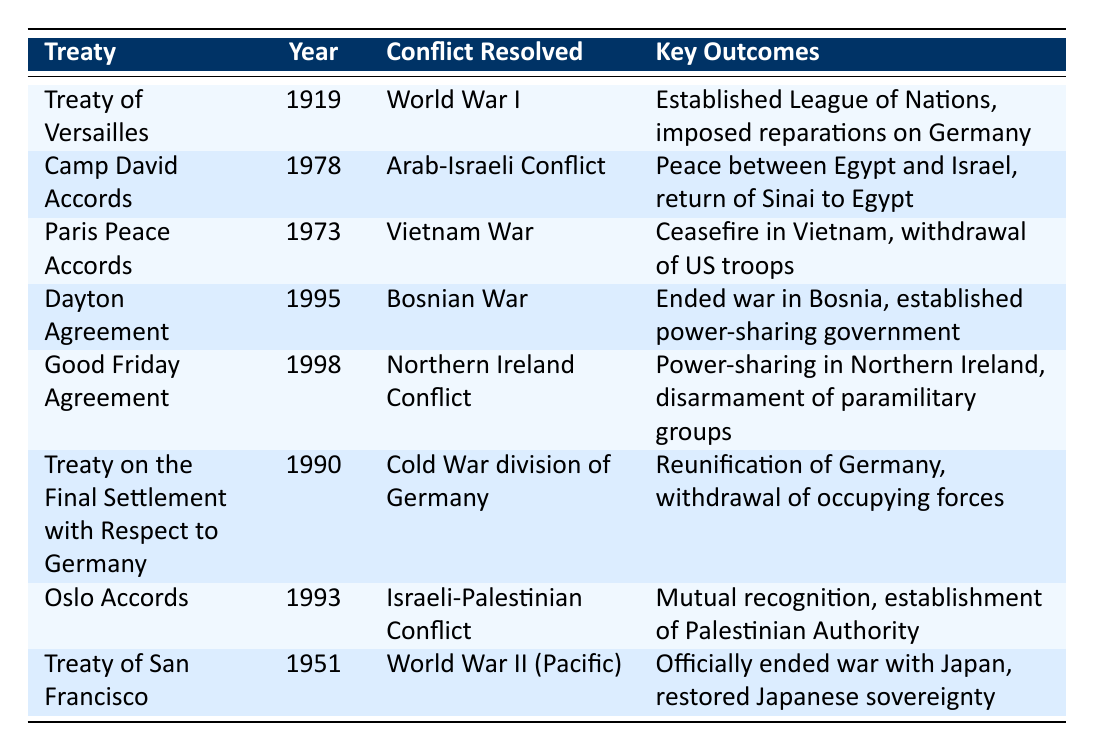What year was the Treaty of Versailles signed? The table lists the year for the Treaty of Versailles in the "Year" column, which indicates it was signed in 1919.
Answer: 1919 What key outcome is associated with the Paris Peace Accords? According to the table under the "Key Outcomes" column for the Paris Peace Accords, the key outcome is a ceasefire in Vietnam and the withdrawal of US troops.
Answer: Ceasefire in Vietnam, withdrawal of US troops Did the Dayton Agreement resolve the conflict in Bosnia? The table specifies that the Dayton Agreement resolved the Bosnian War; thus, it is confirmed that yes, it did resolve the conflict.
Answer: Yes Which treaty established the League of Nations? The table shows that the Treaty of Versailles (1919) established the League of Nations as one of its key outcomes.
Answer: Treaty of Versailles How many treaties focused on resolving conflicts in the Middle East? The table identifies two treaties that dealt with Middle Eastern conflicts: the Camp David Accords (1978) and the Oslo Accords (1993), making a total of two.
Answer: 2 What was a major outcome of the Treaty on the Final Settlement with Respect to Germany? Referring to the table, the major outcome listed is the reunification of Germany and the withdrawal of occupying forces.
Answer: Reunification of Germany Was the Treaty of San Francisco related to World War II? The table indicates that the Treaty of San Francisco officially ended the war with Japan, confirming its relationship to World War II, so the answer is yes.
Answer: Yes What is the difference in years between the signing of the Camp David Accords and the Good Friday Agreement? The Camp David Accords were signed in 1978, while the Good Friday Agreement was signed in 1998. The difference is calculated as 1998 - 1978 = 20 years.
Answer: 20 years How many treaties focused on power-sharing agreements? The table lists two treaties associated with power-sharing outcomes: the Dayton Agreement (1995) and the Good Friday Agreement (1998). Thus, there are two treaties that include power-sharing agreements.
Answer: 2 